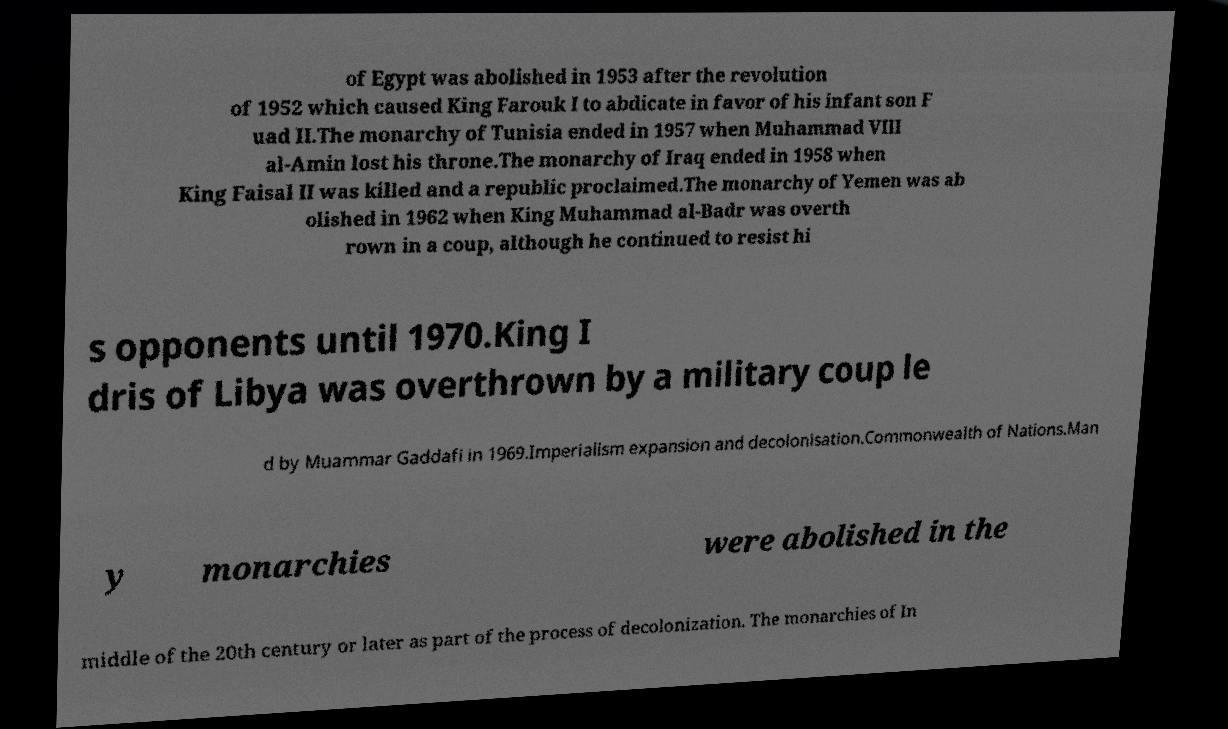Could you extract and type out the text from this image? of Egypt was abolished in 1953 after the revolution of 1952 which caused King Farouk I to abdicate in favor of his infant son F uad II.The monarchy of Tunisia ended in 1957 when Muhammad VIII al-Amin lost his throne.The monarchy of Iraq ended in 1958 when King Faisal II was killed and a republic proclaimed.The monarchy of Yemen was ab olished in 1962 when King Muhammad al-Badr was overth rown in a coup, although he continued to resist hi s opponents until 1970.King I dris of Libya was overthrown by a military coup le d by Muammar Gaddafi in 1969.Imperialism expansion and decolonisation.Commonwealth of Nations.Man y monarchies were abolished in the middle of the 20th century or later as part of the process of decolonization. The monarchies of In 